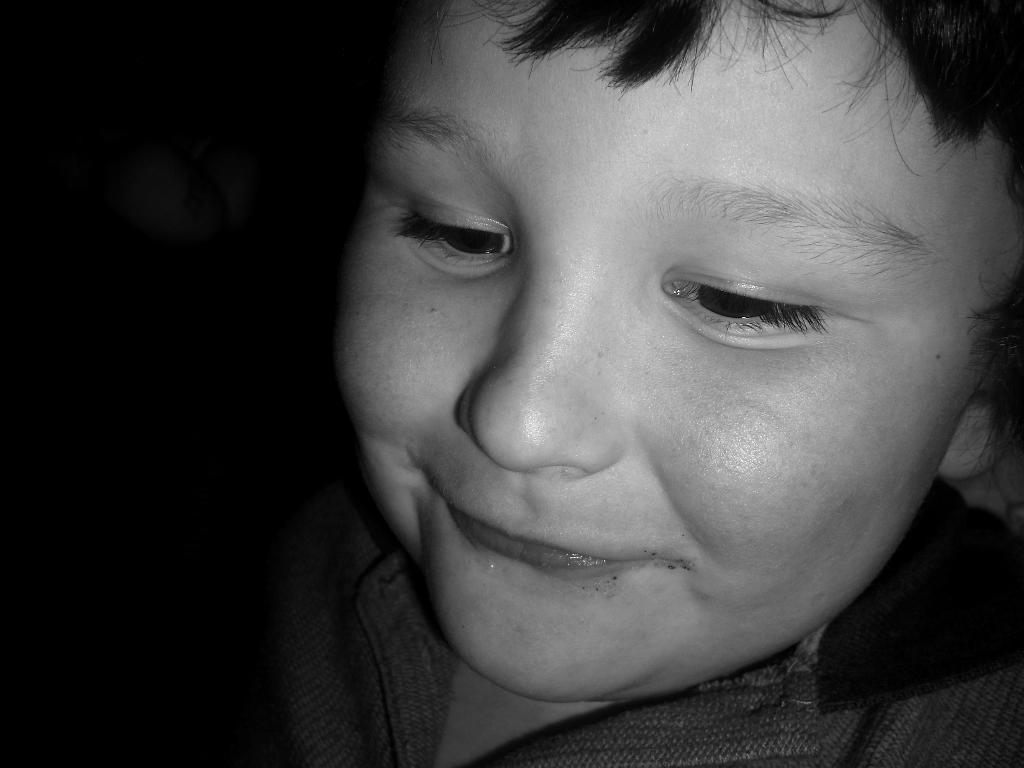What is the main subject of the image? The main subject of the image is a boy. What expression does the boy have in the image? The boy is smiling in the image. How many sisters does the boy have in the image? There is no information about the boy's sisters in the image. What type of curve can be seen in the image? There is no curve present in the image. 